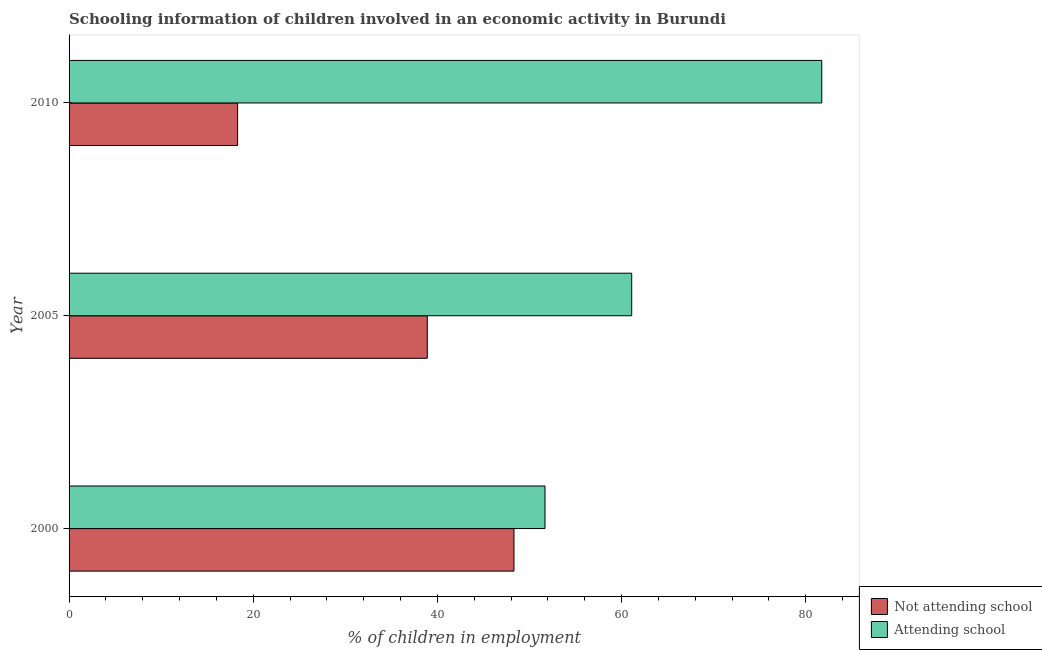How many bars are there on the 2nd tick from the top?
Provide a short and direct response. 2. What is the percentage of employed children who are not attending school in 2005?
Give a very brief answer. 38.9. Across all years, what is the maximum percentage of employed children who are not attending school?
Offer a very short reply. 48.32. Across all years, what is the minimum percentage of employed children who are attending school?
Offer a very short reply. 51.68. In which year was the percentage of employed children who are attending school minimum?
Keep it short and to the point. 2000. What is the total percentage of employed children who are not attending school in the graph?
Offer a terse response. 105.52. What is the difference between the percentage of employed children who are attending school in 2000 and that in 2010?
Your answer should be very brief. -30.05. What is the difference between the percentage of employed children who are not attending school in 2010 and the percentage of employed children who are attending school in 2005?
Give a very brief answer. -42.8. What is the average percentage of employed children who are not attending school per year?
Offer a very short reply. 35.17. In the year 2010, what is the difference between the percentage of employed children who are not attending school and percentage of employed children who are attending school?
Provide a succinct answer. -63.44. What is the ratio of the percentage of employed children who are not attending school in 2000 to that in 2010?
Give a very brief answer. 2.64. Is the difference between the percentage of employed children who are attending school in 2005 and 2010 greater than the difference between the percentage of employed children who are not attending school in 2005 and 2010?
Your answer should be compact. No. What is the difference between the highest and the second highest percentage of employed children who are attending school?
Give a very brief answer. 20.64. What is the difference between the highest and the lowest percentage of employed children who are attending school?
Ensure brevity in your answer.  30.05. What does the 1st bar from the top in 2005 represents?
Ensure brevity in your answer.  Attending school. What does the 2nd bar from the bottom in 2000 represents?
Keep it short and to the point. Attending school. How many bars are there?
Your answer should be very brief. 6. Are the values on the major ticks of X-axis written in scientific E-notation?
Offer a very short reply. No. Where does the legend appear in the graph?
Your answer should be compact. Bottom right. What is the title of the graph?
Provide a succinct answer. Schooling information of children involved in an economic activity in Burundi. What is the label or title of the X-axis?
Offer a very short reply. % of children in employment. What is the % of children in employment in Not attending school in 2000?
Keep it short and to the point. 48.32. What is the % of children in employment of Attending school in 2000?
Make the answer very short. 51.68. What is the % of children in employment in Not attending school in 2005?
Your response must be concise. 38.9. What is the % of children in employment in Attending school in 2005?
Make the answer very short. 61.1. What is the % of children in employment in Attending school in 2010?
Provide a short and direct response. 81.74. Across all years, what is the maximum % of children in employment of Not attending school?
Ensure brevity in your answer.  48.32. Across all years, what is the maximum % of children in employment in Attending school?
Provide a succinct answer. 81.74. Across all years, what is the minimum % of children in employment in Not attending school?
Ensure brevity in your answer.  18.3. Across all years, what is the minimum % of children in employment of Attending school?
Offer a very short reply. 51.68. What is the total % of children in employment of Not attending school in the graph?
Provide a short and direct response. 105.52. What is the total % of children in employment of Attending school in the graph?
Your answer should be compact. 194.52. What is the difference between the % of children in employment of Not attending school in 2000 and that in 2005?
Your response must be concise. 9.42. What is the difference between the % of children in employment in Attending school in 2000 and that in 2005?
Ensure brevity in your answer.  -9.42. What is the difference between the % of children in employment in Not attending school in 2000 and that in 2010?
Make the answer very short. 30.02. What is the difference between the % of children in employment in Attending school in 2000 and that in 2010?
Your response must be concise. -30.05. What is the difference between the % of children in employment of Not attending school in 2005 and that in 2010?
Your answer should be very brief. 20.6. What is the difference between the % of children in employment of Attending school in 2005 and that in 2010?
Your answer should be compact. -20.64. What is the difference between the % of children in employment in Not attending school in 2000 and the % of children in employment in Attending school in 2005?
Make the answer very short. -12.78. What is the difference between the % of children in employment in Not attending school in 2000 and the % of children in employment in Attending school in 2010?
Your answer should be very brief. -33.42. What is the difference between the % of children in employment of Not attending school in 2005 and the % of children in employment of Attending school in 2010?
Your response must be concise. -42.84. What is the average % of children in employment of Not attending school per year?
Keep it short and to the point. 35.17. What is the average % of children in employment in Attending school per year?
Offer a very short reply. 64.84. In the year 2000, what is the difference between the % of children in employment in Not attending school and % of children in employment in Attending school?
Keep it short and to the point. -3.37. In the year 2005, what is the difference between the % of children in employment in Not attending school and % of children in employment in Attending school?
Provide a succinct answer. -22.2. In the year 2010, what is the difference between the % of children in employment in Not attending school and % of children in employment in Attending school?
Provide a short and direct response. -63.44. What is the ratio of the % of children in employment in Not attending school in 2000 to that in 2005?
Offer a very short reply. 1.24. What is the ratio of the % of children in employment of Attending school in 2000 to that in 2005?
Offer a terse response. 0.85. What is the ratio of the % of children in employment of Not attending school in 2000 to that in 2010?
Your answer should be compact. 2.64. What is the ratio of the % of children in employment of Attending school in 2000 to that in 2010?
Provide a short and direct response. 0.63. What is the ratio of the % of children in employment of Not attending school in 2005 to that in 2010?
Offer a very short reply. 2.13. What is the ratio of the % of children in employment of Attending school in 2005 to that in 2010?
Ensure brevity in your answer.  0.75. What is the difference between the highest and the second highest % of children in employment of Not attending school?
Ensure brevity in your answer.  9.42. What is the difference between the highest and the second highest % of children in employment in Attending school?
Ensure brevity in your answer.  20.64. What is the difference between the highest and the lowest % of children in employment in Not attending school?
Ensure brevity in your answer.  30.02. What is the difference between the highest and the lowest % of children in employment of Attending school?
Ensure brevity in your answer.  30.05. 